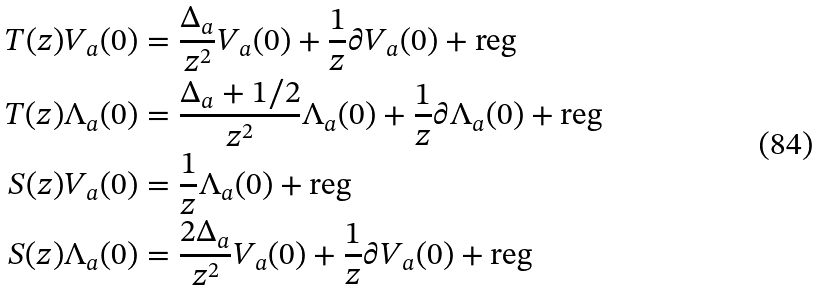Convert formula to latex. <formula><loc_0><loc_0><loc_500><loc_500>T ( z ) V _ { a } ( 0 ) & = \frac { \Delta _ { a } } { z ^ { 2 } } V _ { a } ( 0 ) + \frac { 1 } { z } \partial V _ { a } ( 0 ) + \text {reg} \\ T ( z ) \Lambda _ { a } ( 0 ) & = \frac { \Delta _ { a } + 1 / 2 } { z ^ { 2 } } \Lambda _ { a } ( 0 ) + \frac { 1 } { z } \partial \Lambda _ { a } ( 0 ) + \text {reg} \\ S ( z ) V _ { a } ( 0 ) & = \frac { 1 } { z } \Lambda _ { a } ( 0 ) + \text {reg} \\ S ( z ) \Lambda _ { a } ( 0 ) & = \frac { 2 \Delta _ { a } } { z ^ { 2 } } V _ { a } ( 0 ) + \frac { 1 } { z } \partial V _ { a } ( 0 ) + \text {reg}</formula> 